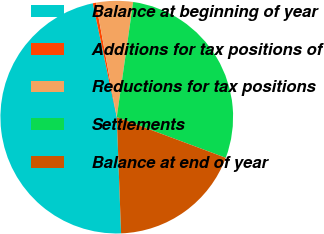Convert chart to OTSL. <chart><loc_0><loc_0><loc_500><loc_500><pie_chart><fcel>Balance at beginning of year<fcel>Additions for tax positions of<fcel>Reductions for tax positions<fcel>Settlements<fcel>Balance at end of year<nl><fcel>47.29%<fcel>0.43%<fcel>5.12%<fcel>28.43%<fcel>18.72%<nl></chart> 